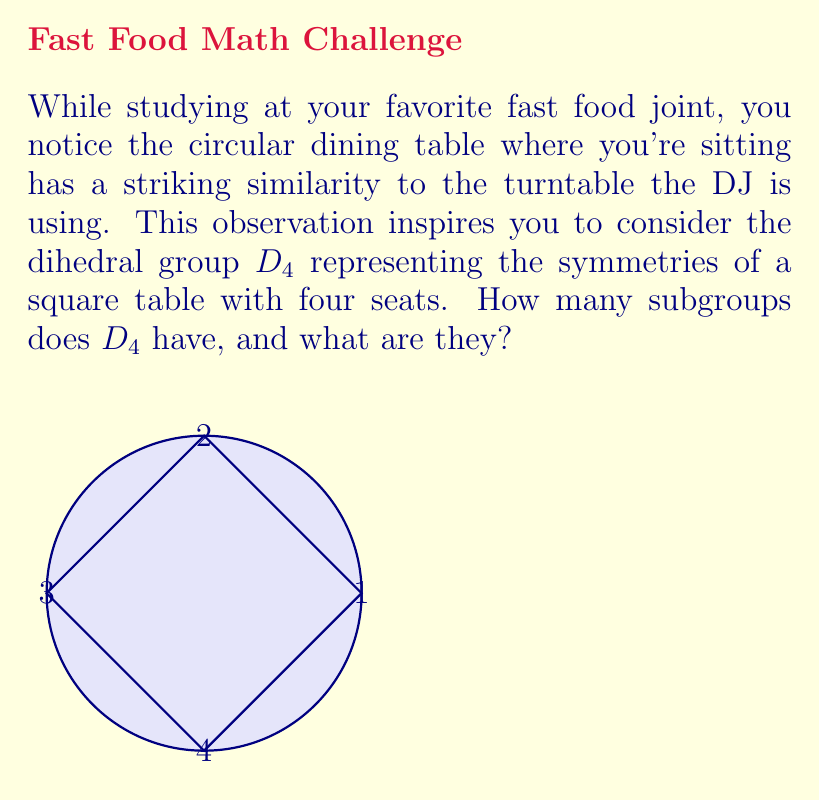Give your solution to this math problem. Let's approach this step-by-step:

1) First, recall that $D_4$ has 8 elements: 4 rotations (including the identity) and 4 reflections.
   $$D_4 = \{e, r, r^2, r^3, s, sr, sr^2, sr^3\}$$
   where $r$ is a 90° rotation and $s$ is a reflection.

2) To find all subgroups, we need to consider all possible combinations of these elements that form a group.

3) The trivial subgroups:
   - $\{e\}$ (order 1)
   - $D_4$ itself (order 8)

4) Cyclic subgroups generated by single elements:
   - $\langle r \rangle = \{e, r, r^2, r^3\}$ (order 4)
   - $\langle r^2 \rangle = \{e, r^2\}$ (order 2)
   - $\langle s \rangle = \{e, s\}$ (order 2)
   - $\langle sr \rangle = \{e, sr\}$ (order 2)
   - $\langle sr^2 \rangle = \{e, sr^2\}$ (order 2)
   - $\langle sr^3 \rangle = \{e, sr^3\}$ (order 2)

5) Non-cyclic subgroup:
   - $\{e, r^2, s, sr^2\}$ (order 4)

6) Counting these up, we have:
   - 1 subgroup of order 1
   - 5 subgroups of order 2
   - 2 subgroups of order 4
   - 1 subgroup of order 8 (D_4 itself)

Therefore, $D_4$ has a total of 9 subgroups.
Answer: 9 subgroups: $\{e\}$, $\{e,r^2\}$, $\{e,s\}$, $\{e,sr\}$, $\{e,sr^2\}$, $\{e,sr^3\}$, $\{e,r,r^2,r^3\}$, $\{e,r^2,s,sr^2\}$, $D_4$ 